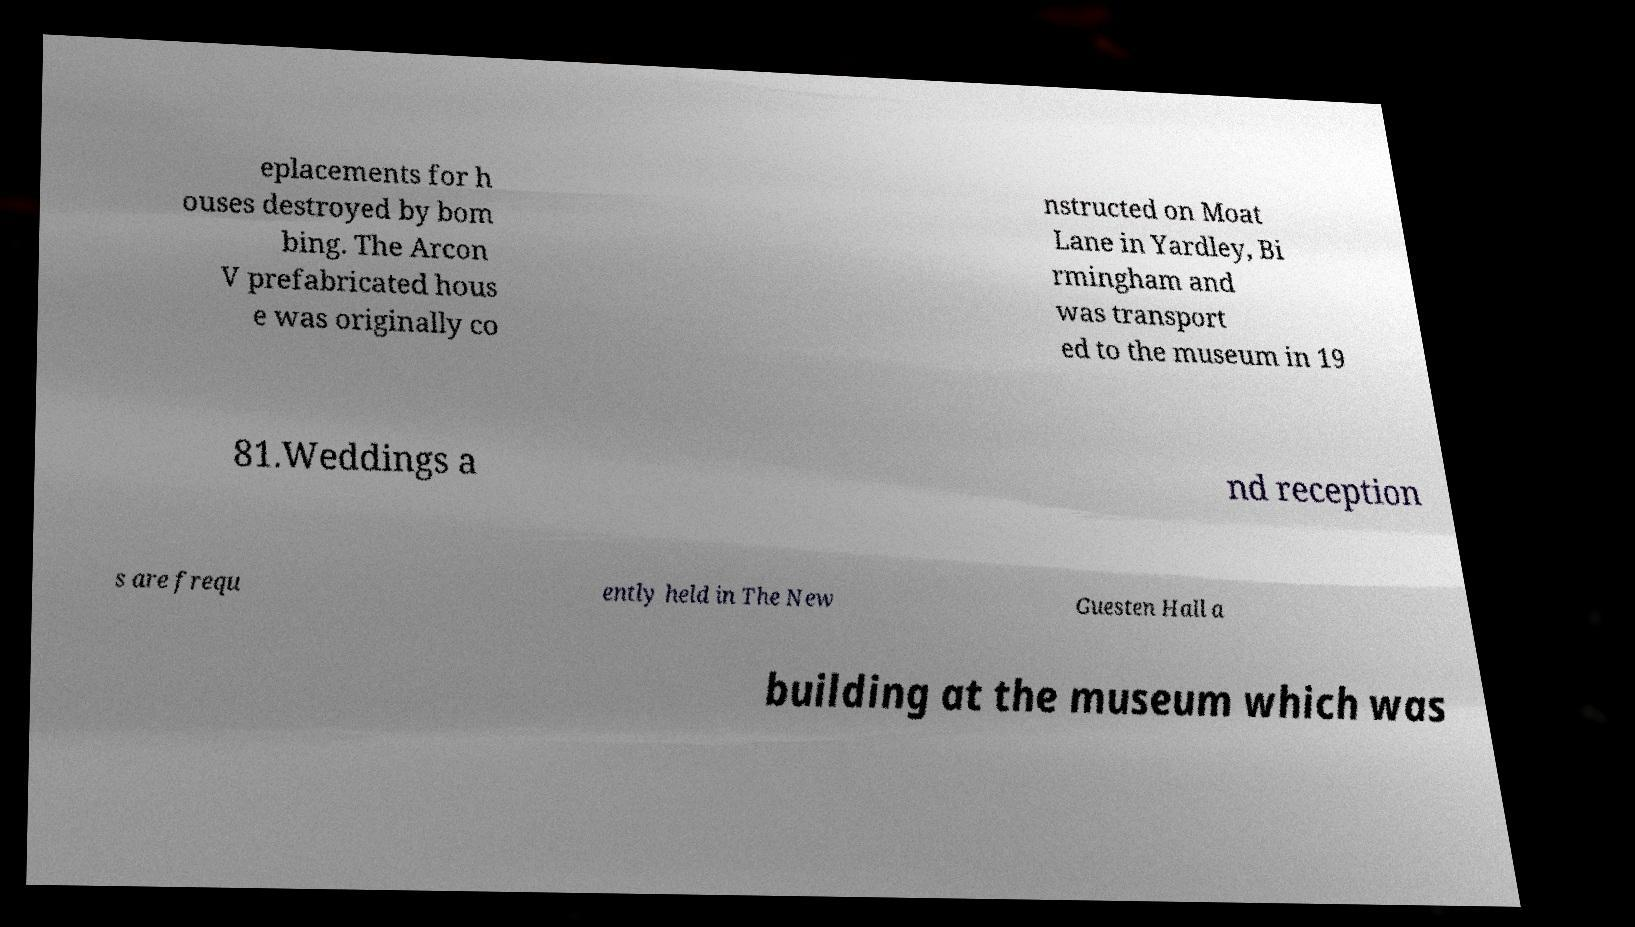There's text embedded in this image that I need extracted. Can you transcribe it verbatim? eplacements for h ouses destroyed by bom bing. The Arcon V prefabricated hous e was originally co nstructed on Moat Lane in Yardley, Bi rmingham and was transport ed to the museum in 19 81.Weddings a nd reception s are frequ ently held in The New Guesten Hall a building at the museum which was 